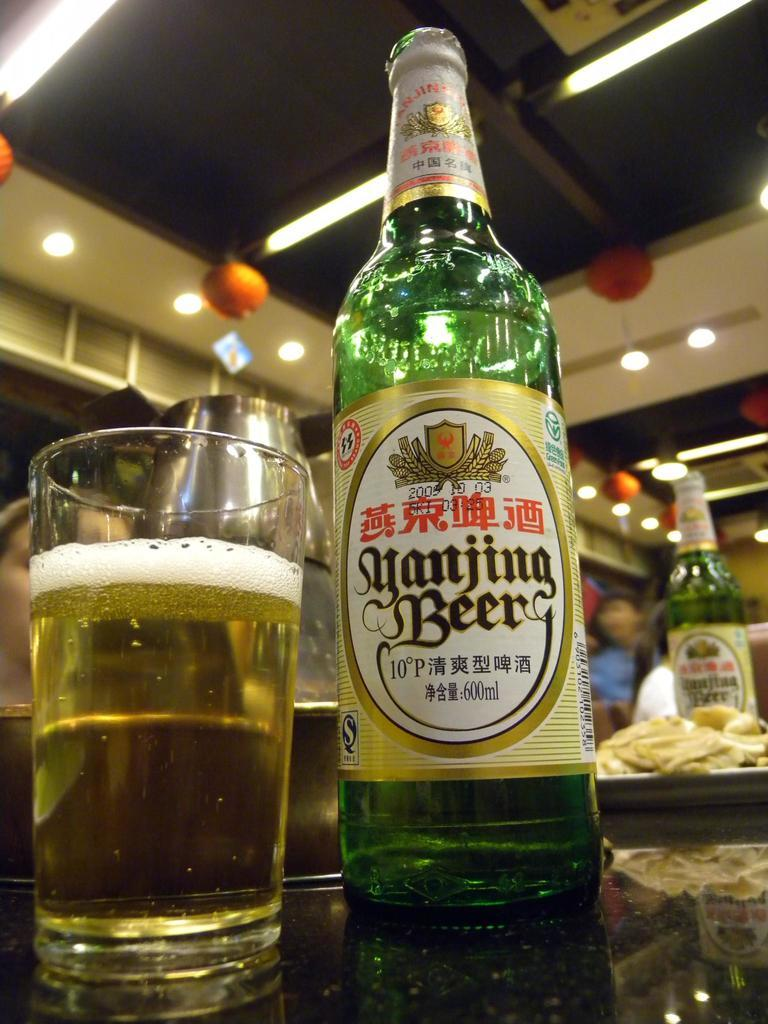<image>
Render a clear and concise summary of the photo. A bottle of Yanjing Beer is next to a glass of beer. 